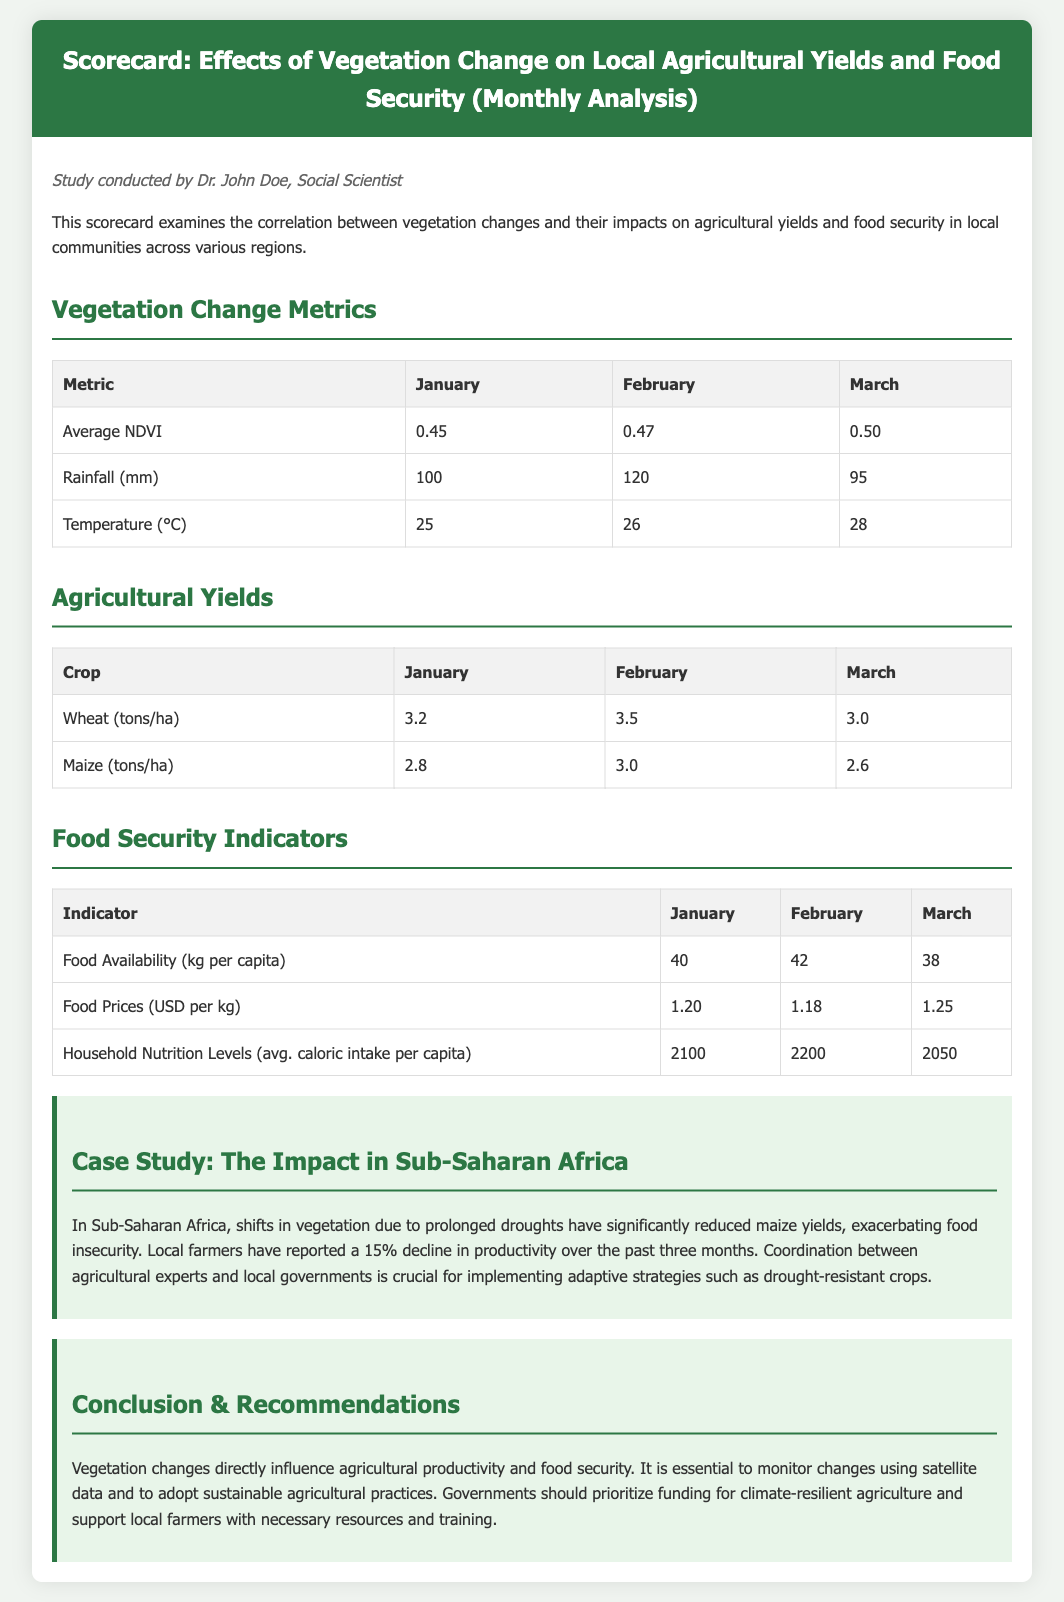What is the average NDVI in March? The average NDVI in March is indicated in the Vegetation Change Metrics table.
Answer: 0.50 What was the rainfall in February? The rainfall in February is listed in the Vegetation Change Metrics table.
Answer: 120 mm Which crop had the highest yield in January? The agricultural yields table indicates that wheat had the highest yield in January.
Answer: Wheat What is the food availability per capita in January? The food availability per capita is found in the Food Security Indicators table.
Answer: 40 kg per capita What percentage decline in maize productivity was reported? The case study section describes a 15% decline in maize productivity.
Answer: 15% What is the average caloric intake per capita in February? The average caloric intake per capita can be found in the Food Security Indicators table for February.
Answer: 2200 What is the food price in March? The food price in March is recorded in the Food Security Indicators table.
Answer: 1.25 USD per kg What is the recommended action for governments? The conclusion section suggests that governments should prioritize funding for climate-resilient agriculture.
Answer: Fund climate-resilient agriculture 